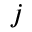<formula> <loc_0><loc_0><loc_500><loc_500>j</formula> 